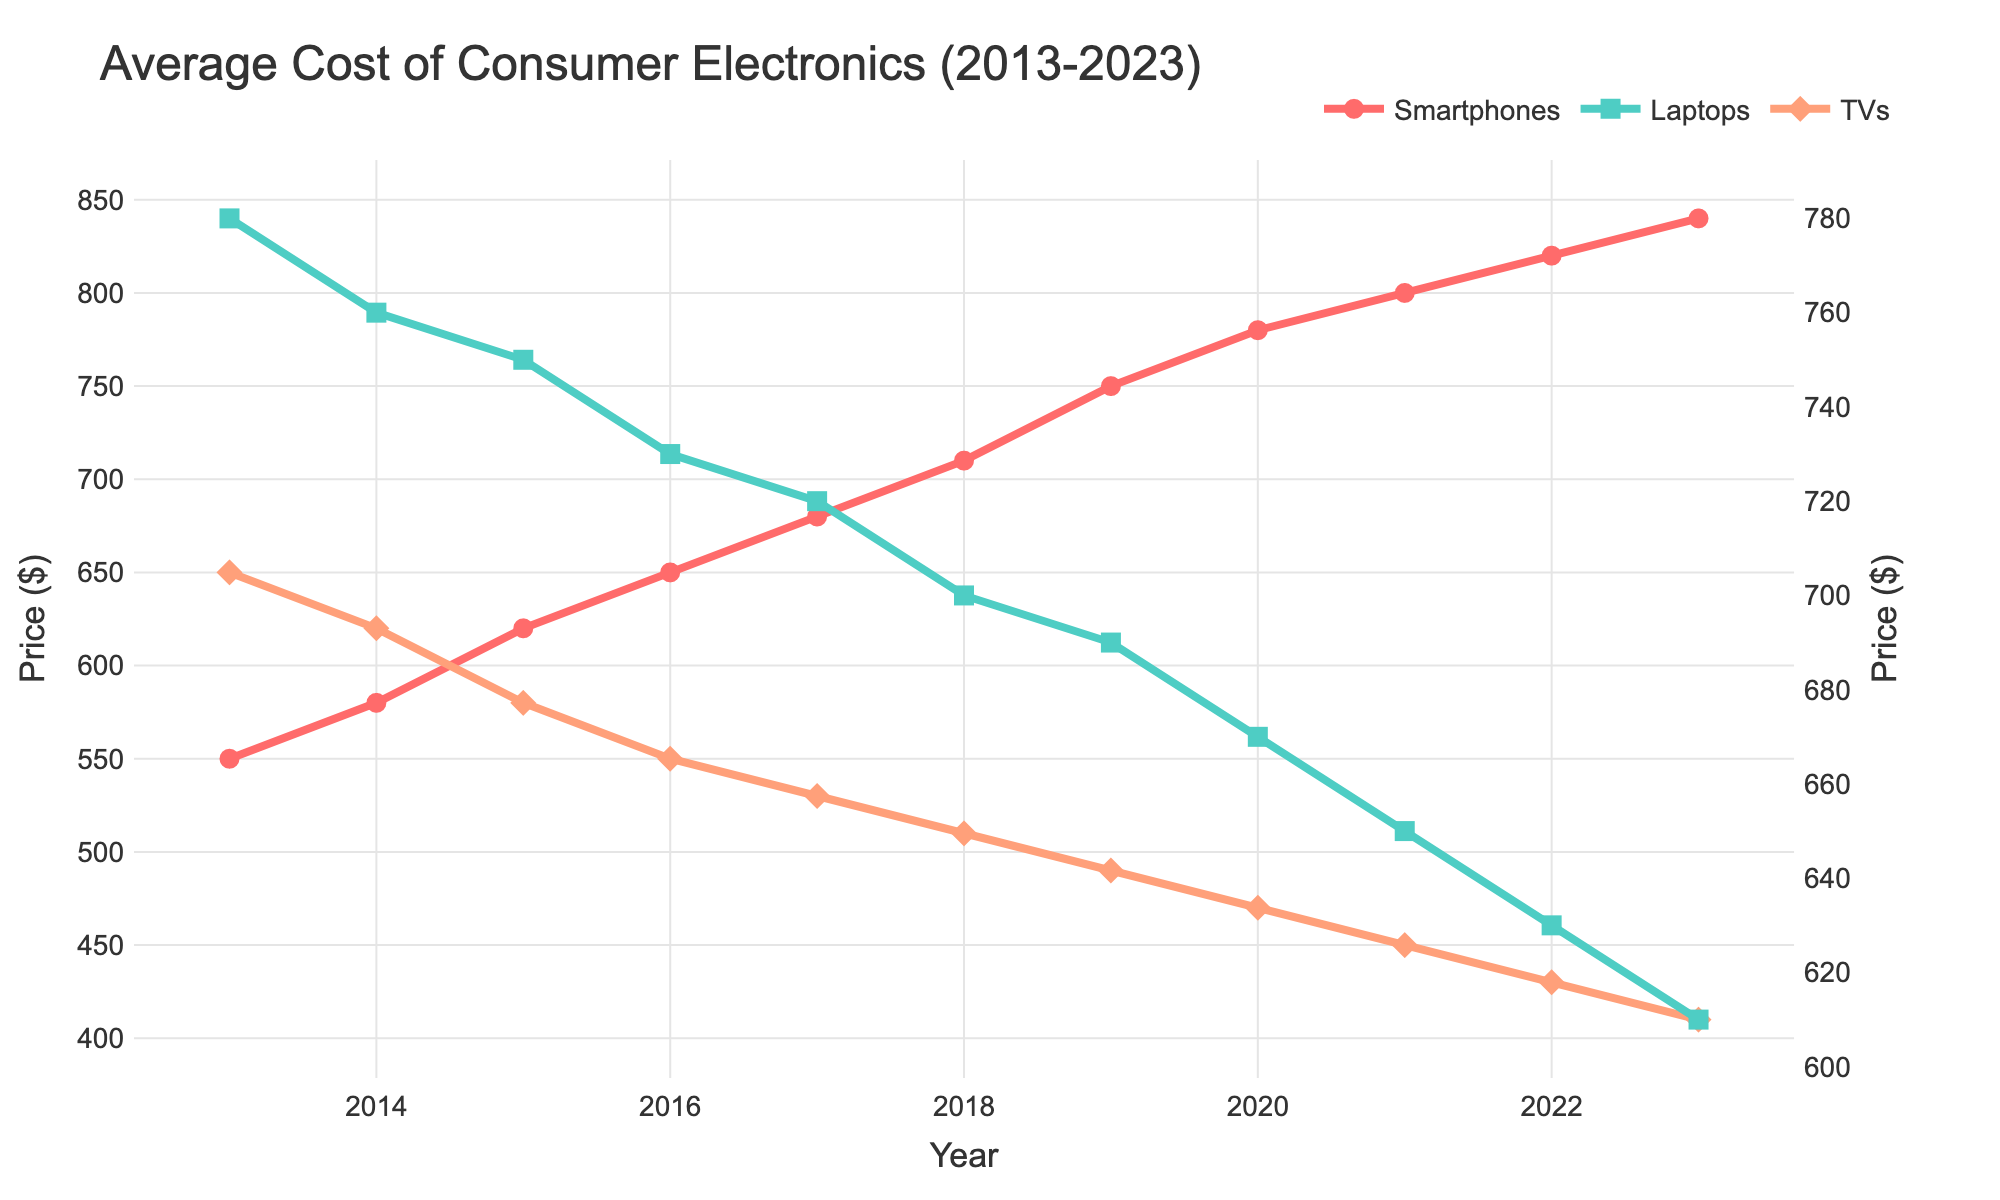What is the general trend for the average cost of smartphones from 2013 to 2023? The line representing smartphones shows a consistent upward trend from 2013 to 2023, indicating that the average cost of smartphones has been increasing over the past decade.
Answer: Increasing Which electronic product had the highest average cost in 2023? The line chart indicates that smartphones had the highest average cost in 2023, with their price at $840, followed by laptops at $610, and TVs at $410.
Answer: Smartphones By how much did the average cost of laptops decrease from 2013 to 2023? In 2013, the average cost of laptops was $780, and in 2023 it was $610. The decrease is calculated by subtracting the 2023 value from the 2013 value: $780 - $610 = $170.
Answer: $170 In what year did smartphones first surpass the $700 average cost mark? The line chart shows that in 2018, the average cost of smartphones was $710, surpassing the $700 mark for the first time.
Answer: 2018 What is the difference between the highest and lowest average cost of TVs over the decade? The highest average cost of TVs was $650 in 2013, and the lowest was $410 in 2023. The difference is $650 - $410 = $240.
Answer: $240 During which period did the average cost of laptops show the steepest decline? The line for laptops shows the steepest decline between the years 2020 and 2023, where the cost dropped from $670 to $610.
Answer: 2020-2023 Which product showed the least variation in average cost over the period 2013 to 2023? By observing the three lines, the line for TVs is the flattest, indicating the least variation in average cost over the decade.
Answer: TVs How much did the average cost of smartphones increase from 2017 to 2020? The average cost of smartphones in 2017 was $680 and in 2020 was $780. The increase is $780 - $680 = $100.
Answer: $100 What was the average cost of laptops in 2015, and how does it compare to the average cost of TVs in the same year? In 2015, the average cost of laptops was $750, and the average cost of TVs was $580. Laptops had a higher average cost compared to TVs by $750 - $580 = $170.
Answer: Laptops were $170 more expensive Identify the product that had the largest increase in average cost from 2013 to 2023 and calculate the increase. Smartphones had the largest increase in average cost from 2013 ($550) to 2023 ($840). The increase is $840 - $550 = $290.
Answer: Smartphones, $290 